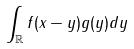Convert formula to latex. <formula><loc_0><loc_0><loc_500><loc_500>\int _ { \mathbb { R } } f ( x - y ) g ( y ) d y</formula> 